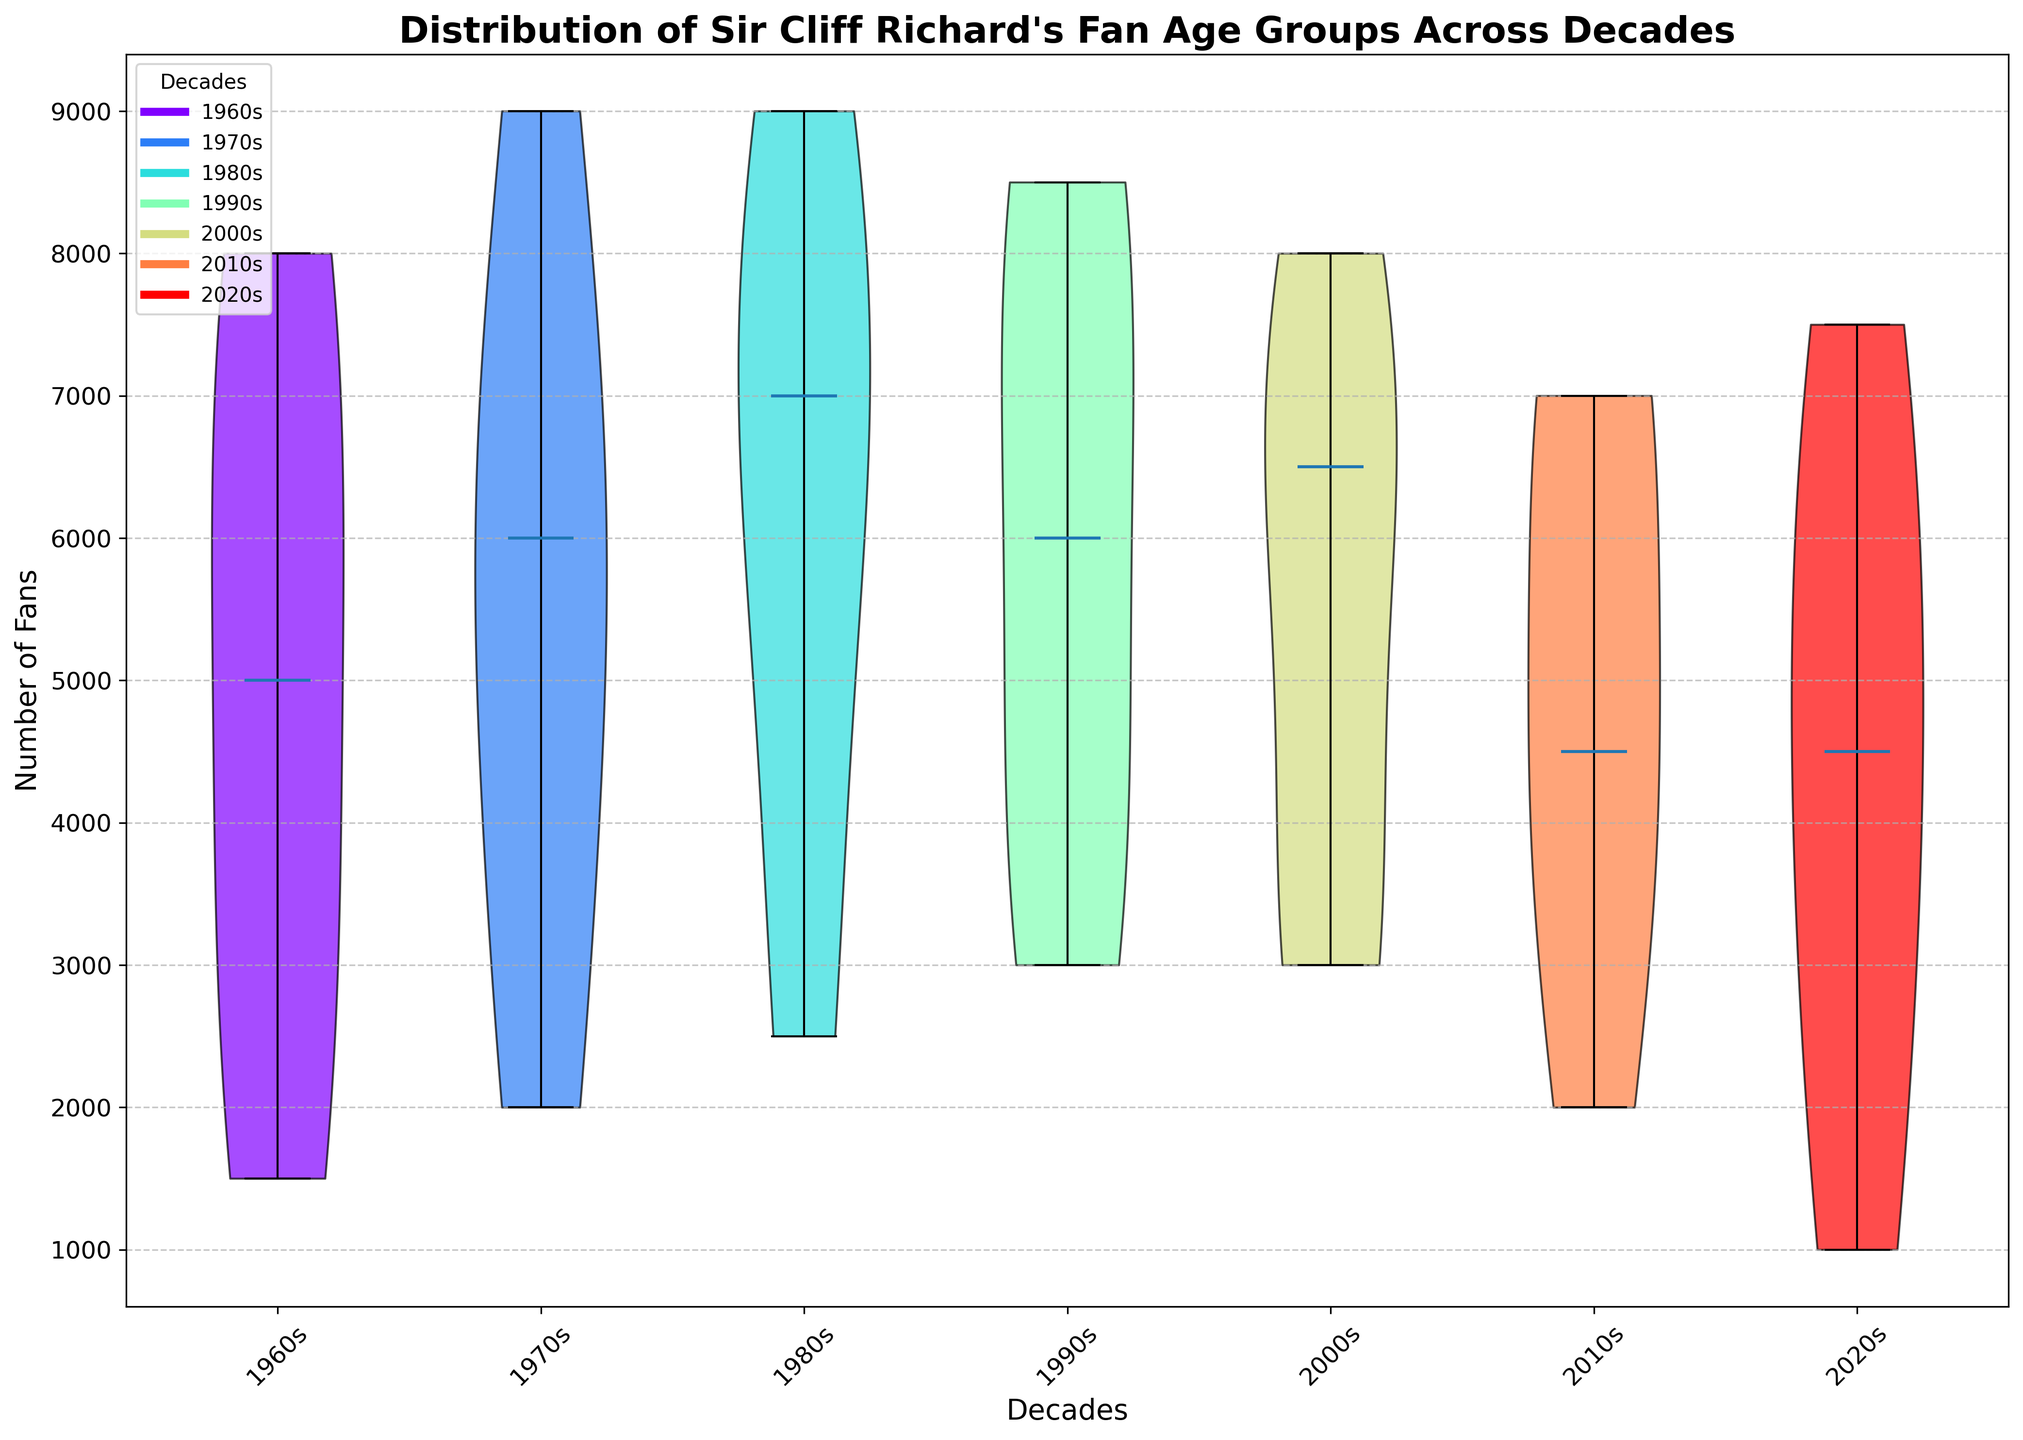What is the title of the violin plot? The title is usually located at the top of the plot. Here, we see it states, "Distribution of Sir Cliff Richard’s Fan Age Groups Across Decades."
Answer: Distribution of Sir Cliff Richard’s Fan Age Groups Across Decades What are the x-axis labels representing in the plot? The x-axis labels represent the different decades, which can be seen from the labels "1960s," "1970s," "1980s," "1990s," "2000s," "2010s," and "2020s."
Answer: Decades What are the y-axis labels showing in the plot? The y-axis labels indicate the number of fans, which is understood from the label "Number of Fans" on the y-axis.
Answer: Number of Fans Which decade has the widest distribution of fan age groups? By observing the spread of the violins, the 1980s show the widest distribution, suggesting a larger variation in the number of fans across the age groups.
Answer: 1980s In which decade is the median number of fans the highest? The median is marked by a white dot in the center of the violins. In this case, the 1980s have the highest median number of fans.
Answer: 1980s Comparing the 1960s and 2020s, which decade had a larger number of fans in the 10-19 age group? The width of the violin of the 10-19 age group is wider for the 1960s compared to the 2020s, indicating a larger number of fans in that age group.
Answer: 1960s Which age group had a consistent number of fans across decades? The violin plots for the age group 50+ appear fairly consistent across decades with a moderate number of fans without significant outliers or variation.
Answer: 50+ Which two decades show a similar distribution in fan numbers for the 40-49 age group? Observing the shape of the violins, the 2000s and 2010s show similar distributions in the 40-49 age group fan numbers, indicated by similarly shaped violins.
Answer: 2000s and 2010s By how much did the number of fans in the 20-29 age group decrease from the 1980s to the 2010s? In the 1980s, the number of fans in the 20-29 age group was around 9000, and it decreased to around 4500 in the 2010s. The decrease is 9000 - 4500 = 4500 fans.
Answer: 4500 fans What is the trend of the fan numbers in the 10-19 age group from the 1960s to the 2020s? Observing the violin plot, there is a noticeable downward trend in the number of fans in the 10-19 age group from the 1960s (highest) to the 2020s (lowest).
Answer: Downward trend 